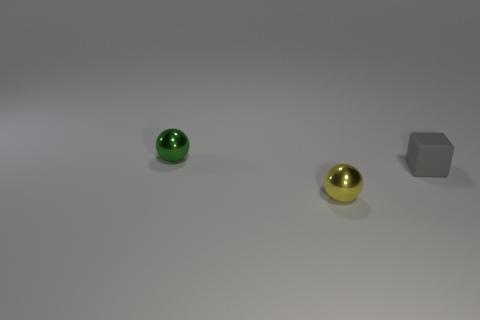Add 1 large blocks. How many objects exist? 4 Subtract all cubes. How many objects are left? 2 Subtract all red matte things. Subtract all metal spheres. How many objects are left? 1 Add 1 small metallic objects. How many small metallic objects are left? 3 Add 3 gray matte cubes. How many gray matte cubes exist? 4 Subtract 0 purple balls. How many objects are left? 3 